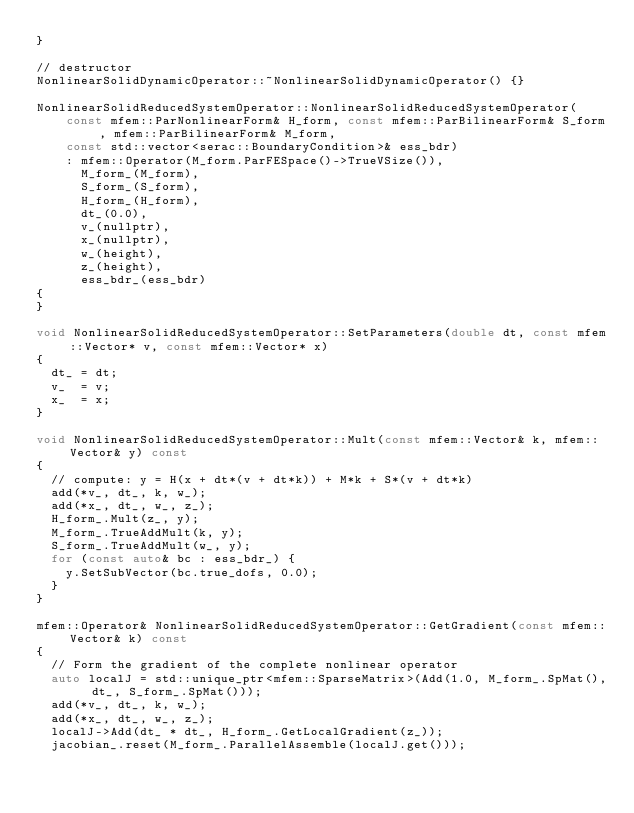<code> <loc_0><loc_0><loc_500><loc_500><_C++_>}

// destructor
NonlinearSolidDynamicOperator::~NonlinearSolidDynamicOperator() {}

NonlinearSolidReducedSystemOperator::NonlinearSolidReducedSystemOperator(
    const mfem::ParNonlinearForm& H_form, const mfem::ParBilinearForm& S_form, mfem::ParBilinearForm& M_form,
    const std::vector<serac::BoundaryCondition>& ess_bdr)
    : mfem::Operator(M_form.ParFESpace()->TrueVSize()),
      M_form_(M_form),
      S_form_(S_form),
      H_form_(H_form),
      dt_(0.0),
      v_(nullptr),
      x_(nullptr),
      w_(height),
      z_(height),
      ess_bdr_(ess_bdr)
{
}

void NonlinearSolidReducedSystemOperator::SetParameters(double dt, const mfem::Vector* v, const mfem::Vector* x)
{
  dt_ = dt;
  v_  = v;
  x_  = x;
}

void NonlinearSolidReducedSystemOperator::Mult(const mfem::Vector& k, mfem::Vector& y) const
{
  // compute: y = H(x + dt*(v + dt*k)) + M*k + S*(v + dt*k)
  add(*v_, dt_, k, w_);
  add(*x_, dt_, w_, z_);
  H_form_.Mult(z_, y);
  M_form_.TrueAddMult(k, y);
  S_form_.TrueAddMult(w_, y);
  for (const auto& bc : ess_bdr_) {
    y.SetSubVector(bc.true_dofs, 0.0);
  }
}

mfem::Operator& NonlinearSolidReducedSystemOperator::GetGradient(const mfem::Vector& k) const
{
  // Form the gradient of the complete nonlinear operator
  auto localJ = std::unique_ptr<mfem::SparseMatrix>(Add(1.0, M_form_.SpMat(), dt_, S_form_.SpMat()));
  add(*v_, dt_, k, w_);
  add(*x_, dt_, w_, z_);
  localJ->Add(dt_ * dt_, H_form_.GetLocalGradient(z_));
  jacobian_.reset(M_form_.ParallelAssemble(localJ.get()));
</code> 